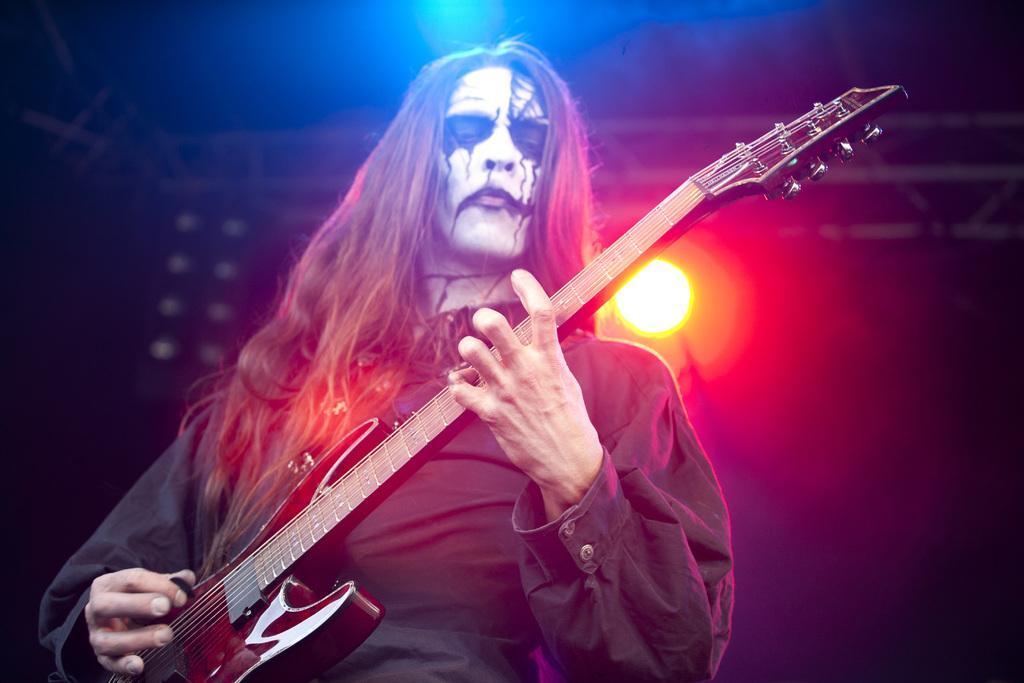How would you summarize this image in a sentence or two? This image consists of a person playing guitar. In the background, there is a light. The person is wearing a black jacket. The guitar is in brown color. 